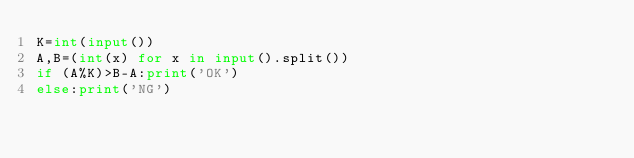<code> <loc_0><loc_0><loc_500><loc_500><_Python_>K=int(input())
A,B=(int(x) for x in input().split())
if (A%K)>B-A:print('OK')
else:print('NG')
</code> 